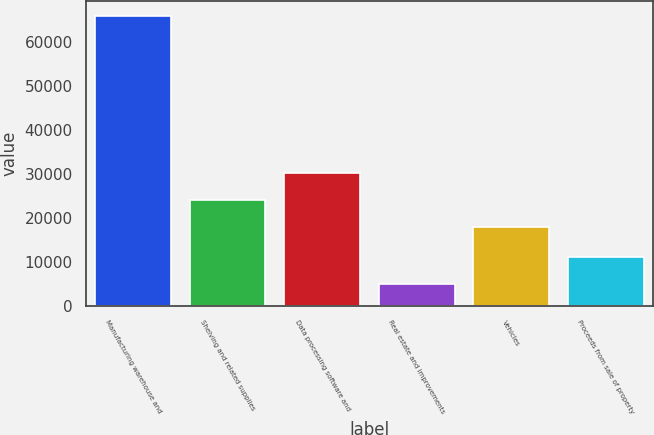Convert chart to OTSL. <chart><loc_0><loc_0><loc_500><loc_500><bar_chart><fcel>Manufacturing warehouse and<fcel>Shelving and related supplies<fcel>Data processing software and<fcel>Real estate and improvements<fcel>Vehicles<fcel>Proceeds from sale of property<nl><fcel>66000<fcel>24100<fcel>30200<fcel>5000<fcel>18000<fcel>11100<nl></chart> 